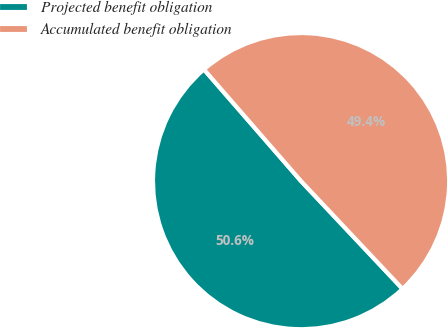Convert chart to OTSL. <chart><loc_0><loc_0><loc_500><loc_500><pie_chart><fcel>Projected benefit obligation<fcel>Accumulated benefit obligation<nl><fcel>50.63%<fcel>49.37%<nl></chart> 